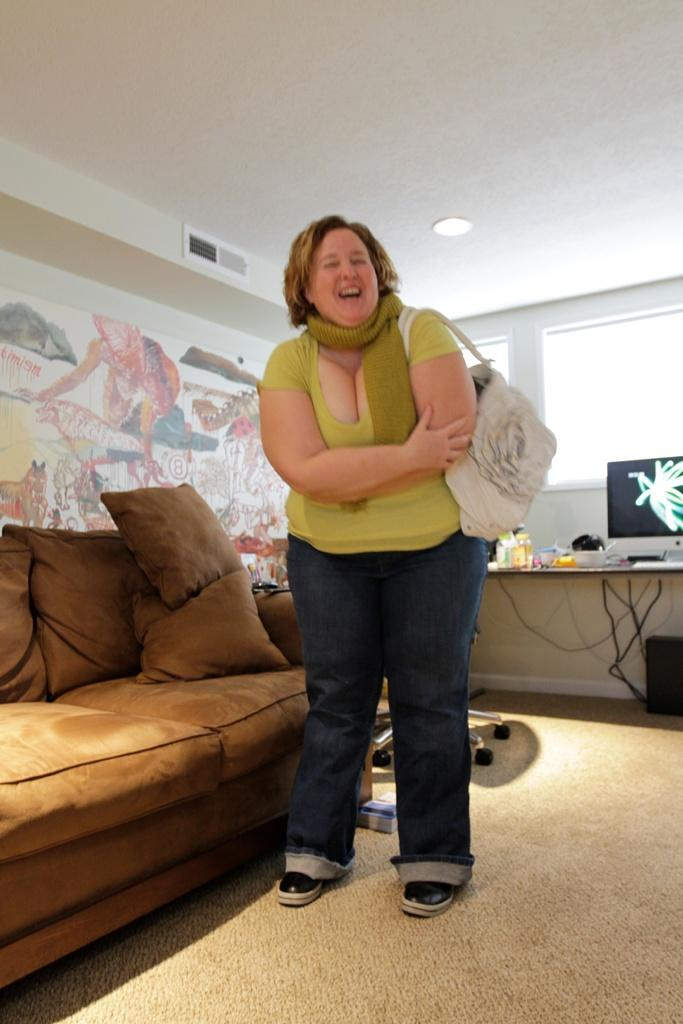What is the main subject in the image? There is a woman standing in the image. What is the woman wearing in the image? The woman is wearing a handbag in the image. What type of furniture is present in the image? There is a couch in the image. What is on the couch in the image? There are pillows on the couch in the image. What type of system can be seen in the image? There is a system (possibly a computer or television) in the image. What is on the table in the image? There are objects on a table in the image. What can be seen on the wall in the image? There is a colorful wall in the image. What architectural feature is present in the image? There is a window in the image. How many children are playing with the toothbrush in the image? There is no toothbrush or children present in the image. What type of flock is visible in the image? There is no flock visible in the image. 